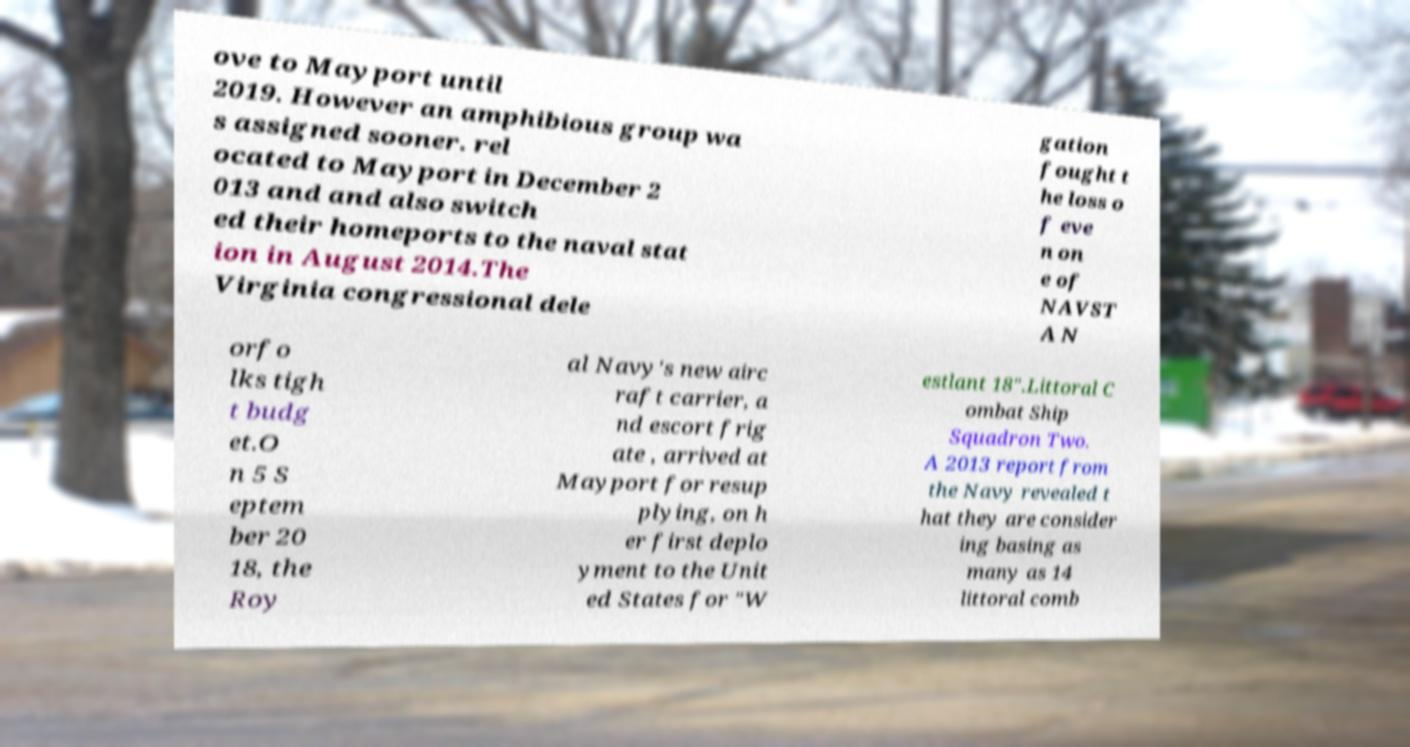Please identify and transcribe the text found in this image. ove to Mayport until 2019. However an amphibious group wa s assigned sooner. rel ocated to Mayport in December 2 013 and and also switch ed their homeports to the naval stat ion in August 2014.The Virginia congressional dele gation fought t he loss o f eve n on e of NAVST A N orfo lks tigh t budg et.O n 5 S eptem ber 20 18, the Roy al Navy's new airc raft carrier, a nd escort frig ate , arrived at Mayport for resup plying, on h er first deplo yment to the Unit ed States for "W estlant 18".Littoral C ombat Ship Squadron Two. A 2013 report from the Navy revealed t hat they are consider ing basing as many as 14 littoral comb 